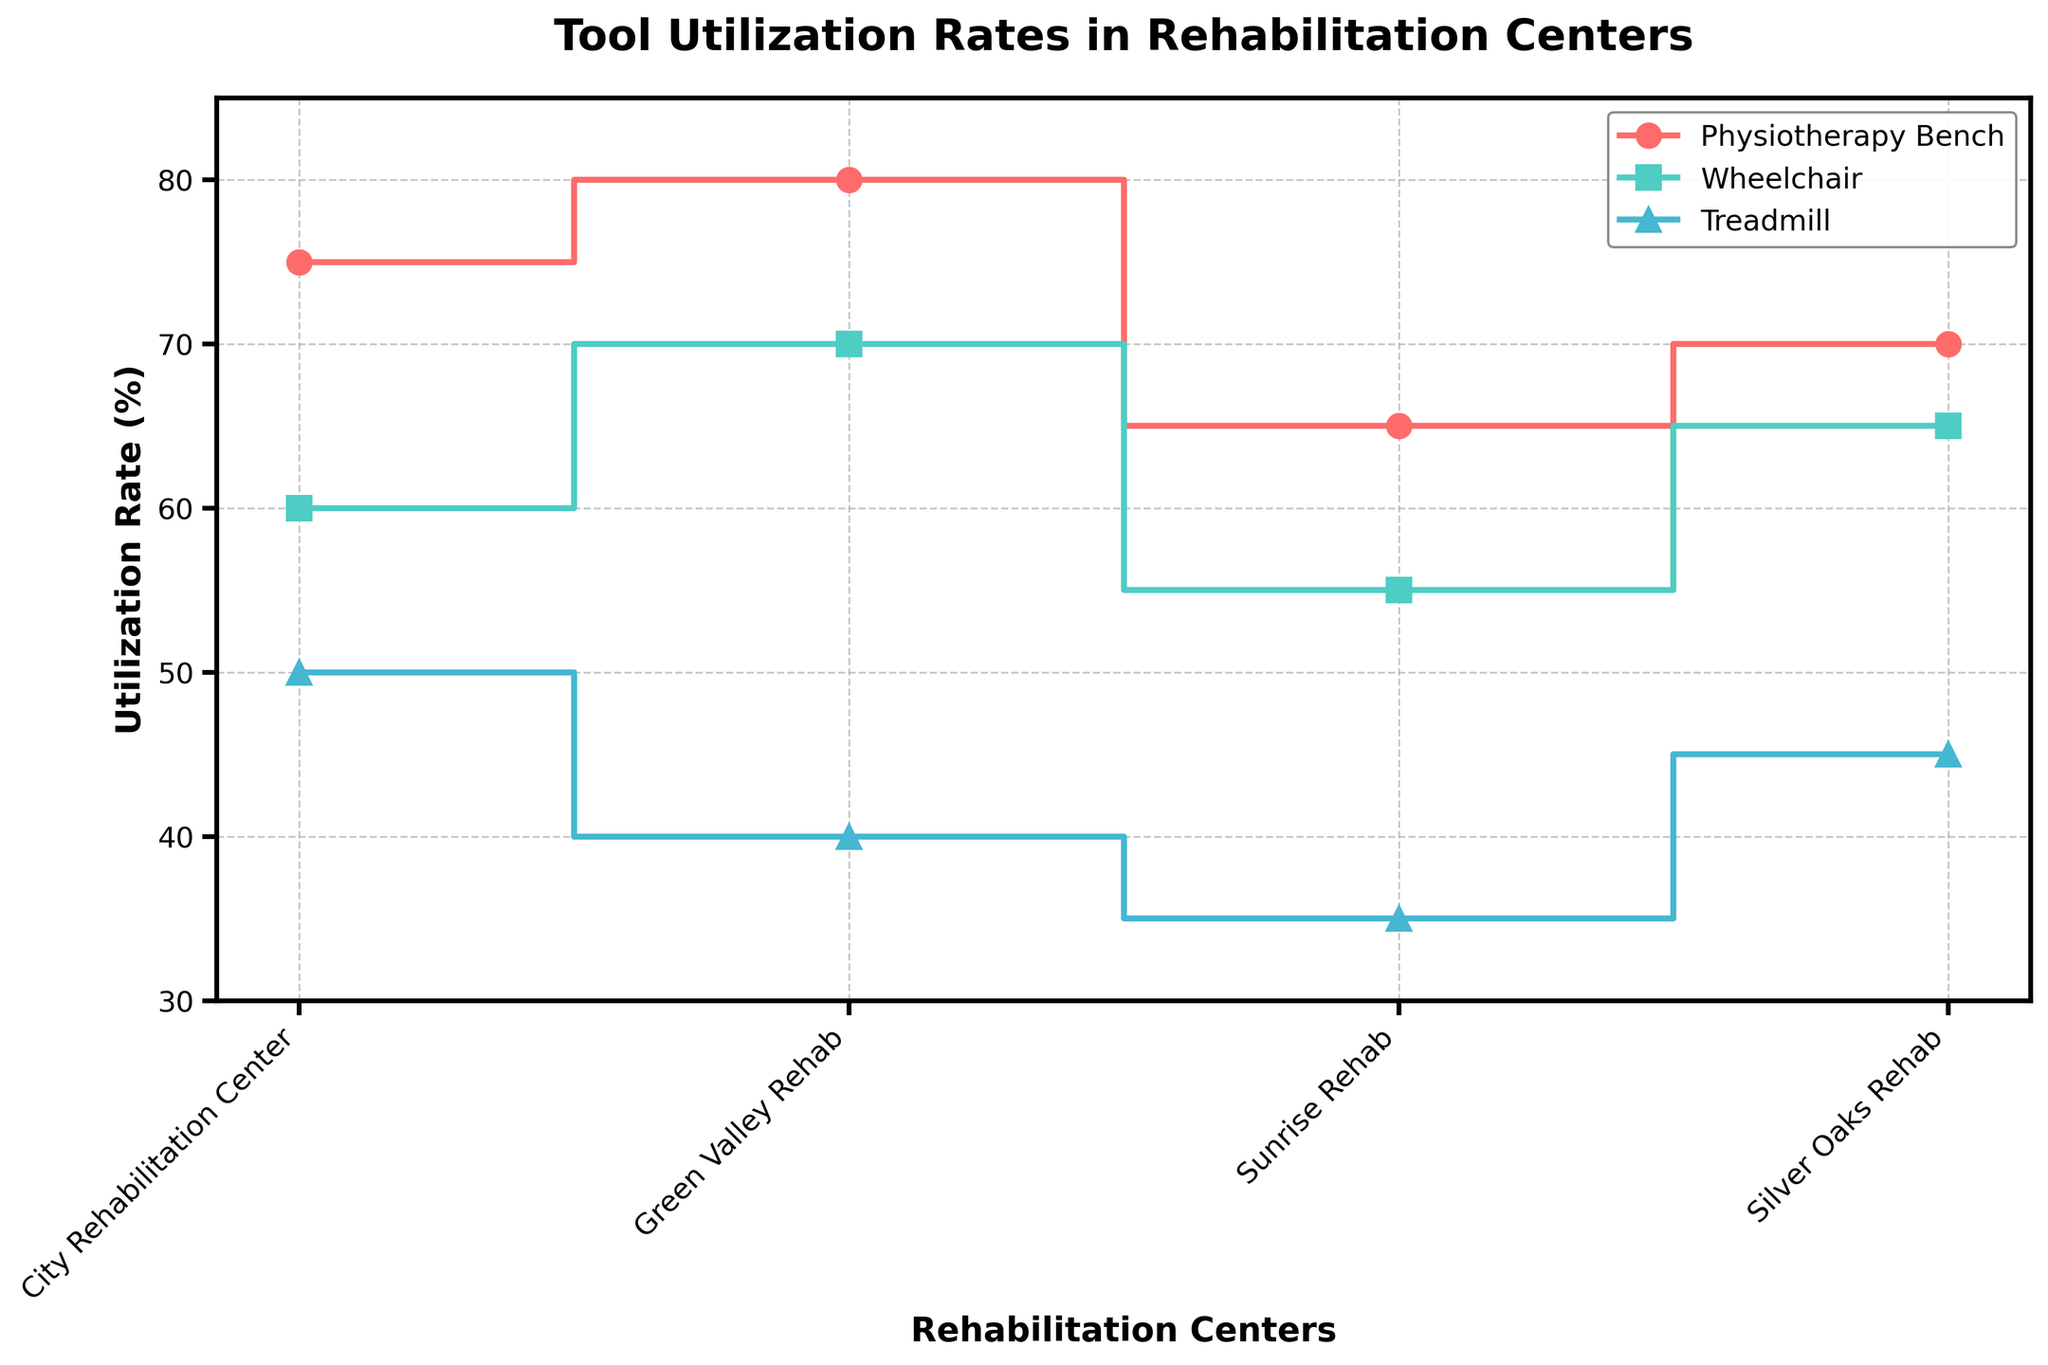What is the title of the figure? The title of the figure is located near the top center of the plot. It provides a summary of the data being visualized.
Answer: Tool Utilization Rates in Rehabilitation Centers What is the utilization rate of the treadmill at Green Valley Rehab? Look at the point where the "Treadmill" line intersects with "Green Valley Rehab" on the x-axis.
Answer: 40% Which rehabilitation center has the highest utilization rate for physiotherapy benches? Identify the highest point on the "Physiotherapy Bench" line and note the corresponding rehabilitation center on the x-axis.
Answer: Green Valley Rehab Which type of equipment has the lowest utilization rate across all rehabilitation centers? Compare all utilization rates for the given types of equipment (Physiotherapy Bench, Wheelchair, Treadmill) across all centers and find the lowest value.
Answer: Treadmill What is the average utilization rate of wheelchairs across all rehabilitation centers? Add the utilization rates of wheelchairs for all four centers: (60 + 70 + 55 + 65) = 250. Divide by the number of centers (4).
Answer: 62.5% Which rehabilitation center has the greatest difference in utilization rates between the physiotherapy bench and the treadmill? Calculate the difference between the physiotherapy bench and treadmill utilization rates for each center and identify the largest difference. For City Rehabilitation Center: 75 - 50 = 25. For Green Valley Rehab: 80 - 40 = 40. For Sunrise Rehab: 65 - 35 = 30. For Silver Oaks Rehab: 70 - 45 = 25.
Answer: Green Valley Rehab Is there any rehabilitation center where all equipment types have utilization rates of 50% or higher? Check the utilization rates for physiotherapy benches, wheelchairs, and treadmills for each center and ensure all are above or equal to 50%.
Answer: City Rehabilitation Center, Green Valley Rehab, Silver Oaks Rehab How does the utilization rate of physiotherapy benches at Silver Oaks Rehab compare to that at Sunrise Rehab? Look at the "Physiotherapy Bench" line for both Silver Oaks Rehab and Sunrise Rehab, and compare the values.
Answer: Silver Oaks Rehab has a higher utilization rate (70% vs. 65%) What is the range of utilization rates for treadmills across all centers? Identify the highest and lowest utilization rates for treadmills across all rehabilitation centers and calculate the difference. The highest is 50% and the lowest is 35%.
Answer: 15% Which piece of equipment at City Rehabilitation Center has the highest utilization rate? Look at the utilization rates for all equipment types at City Rehabilitation Center and identify the highest one.
Answer: Physiotherapy Bench 